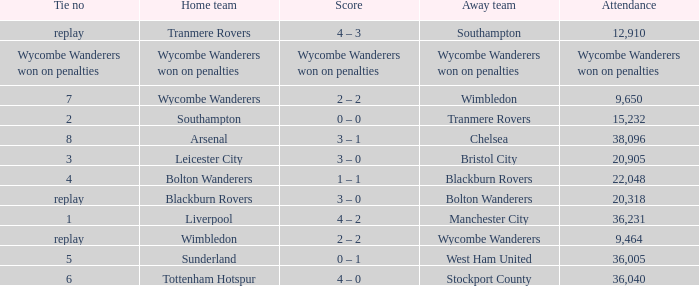What was the score for the match where the home team was Leicester City? 3 – 0. 